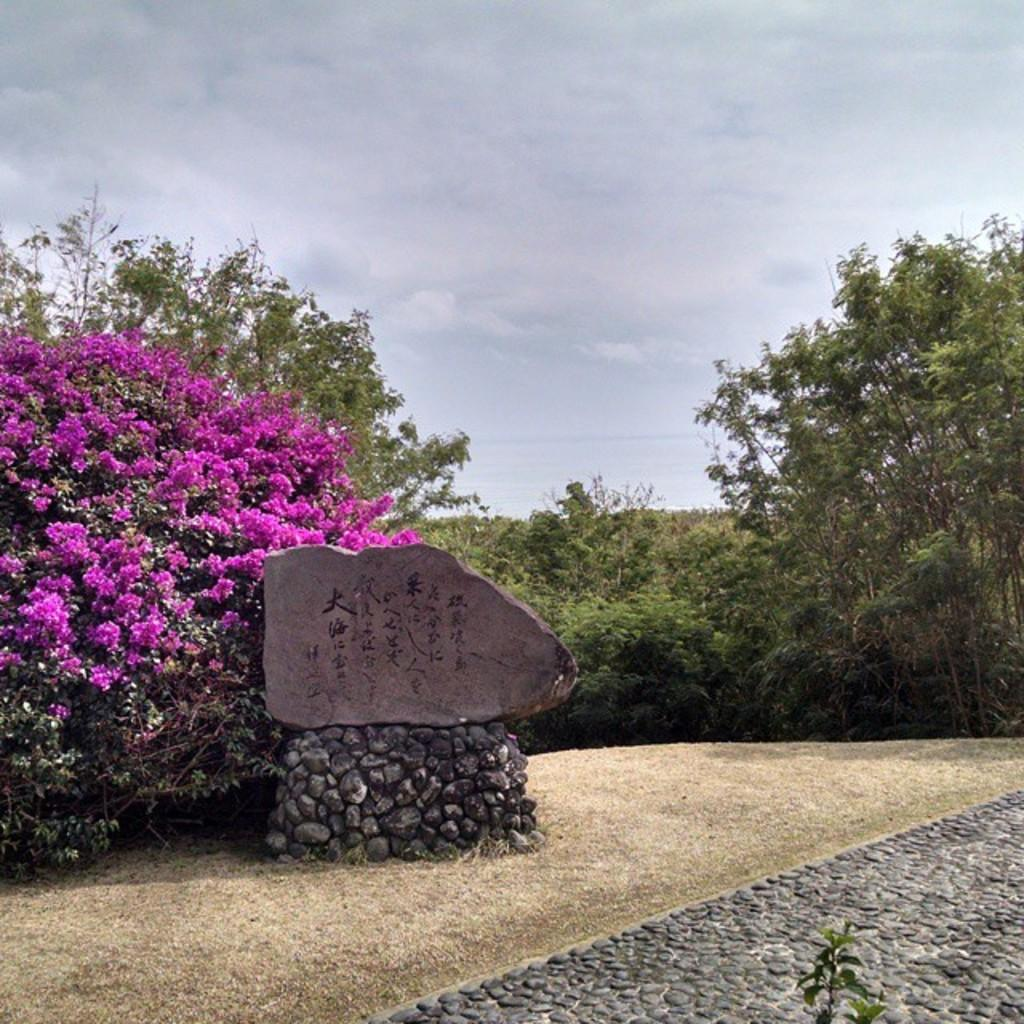Where was the image taken? The image is clicked outside. What can be seen in the middle of the image? There are plants in the middle of the image. What is visible at the top of the image? There is sky visible at the top of the image. What type of plants are on the left side of the image? There are flowers on the left side of the image. What color are the flowers? The flowers are pink in color. What type of soda is being poured into the flowers in the image? There is no soda present in the image; it features flowers and plants. What level of difficulty is the image rated on a scale of 1 to 10? The image is not rated on a scale of difficulty, as it is a photograph and not a task or challenge. 